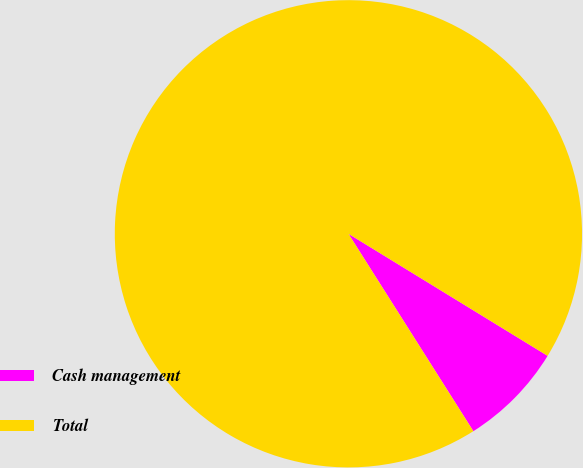<chart> <loc_0><loc_0><loc_500><loc_500><pie_chart><fcel>Cash management<fcel>Total<nl><fcel>7.27%<fcel>92.73%<nl></chart> 